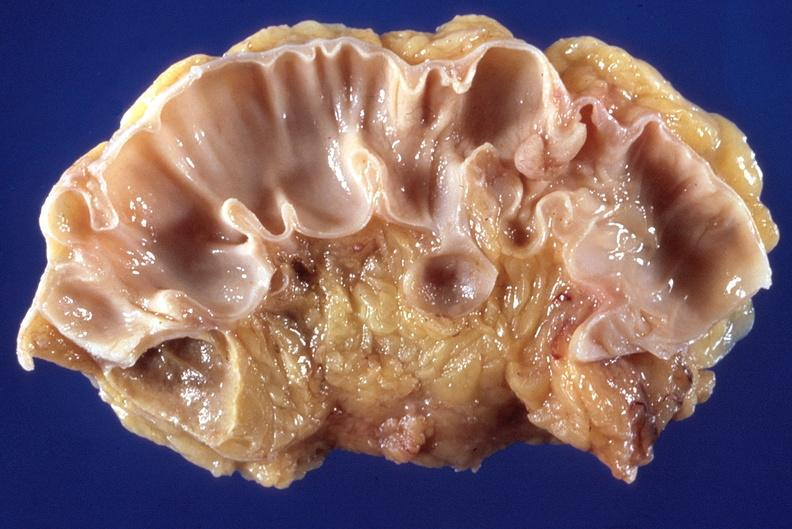does lesion in dome of uterus show sigmoid colon, diverticulosis and polyp?
Answer the question using a single word or phrase. No 